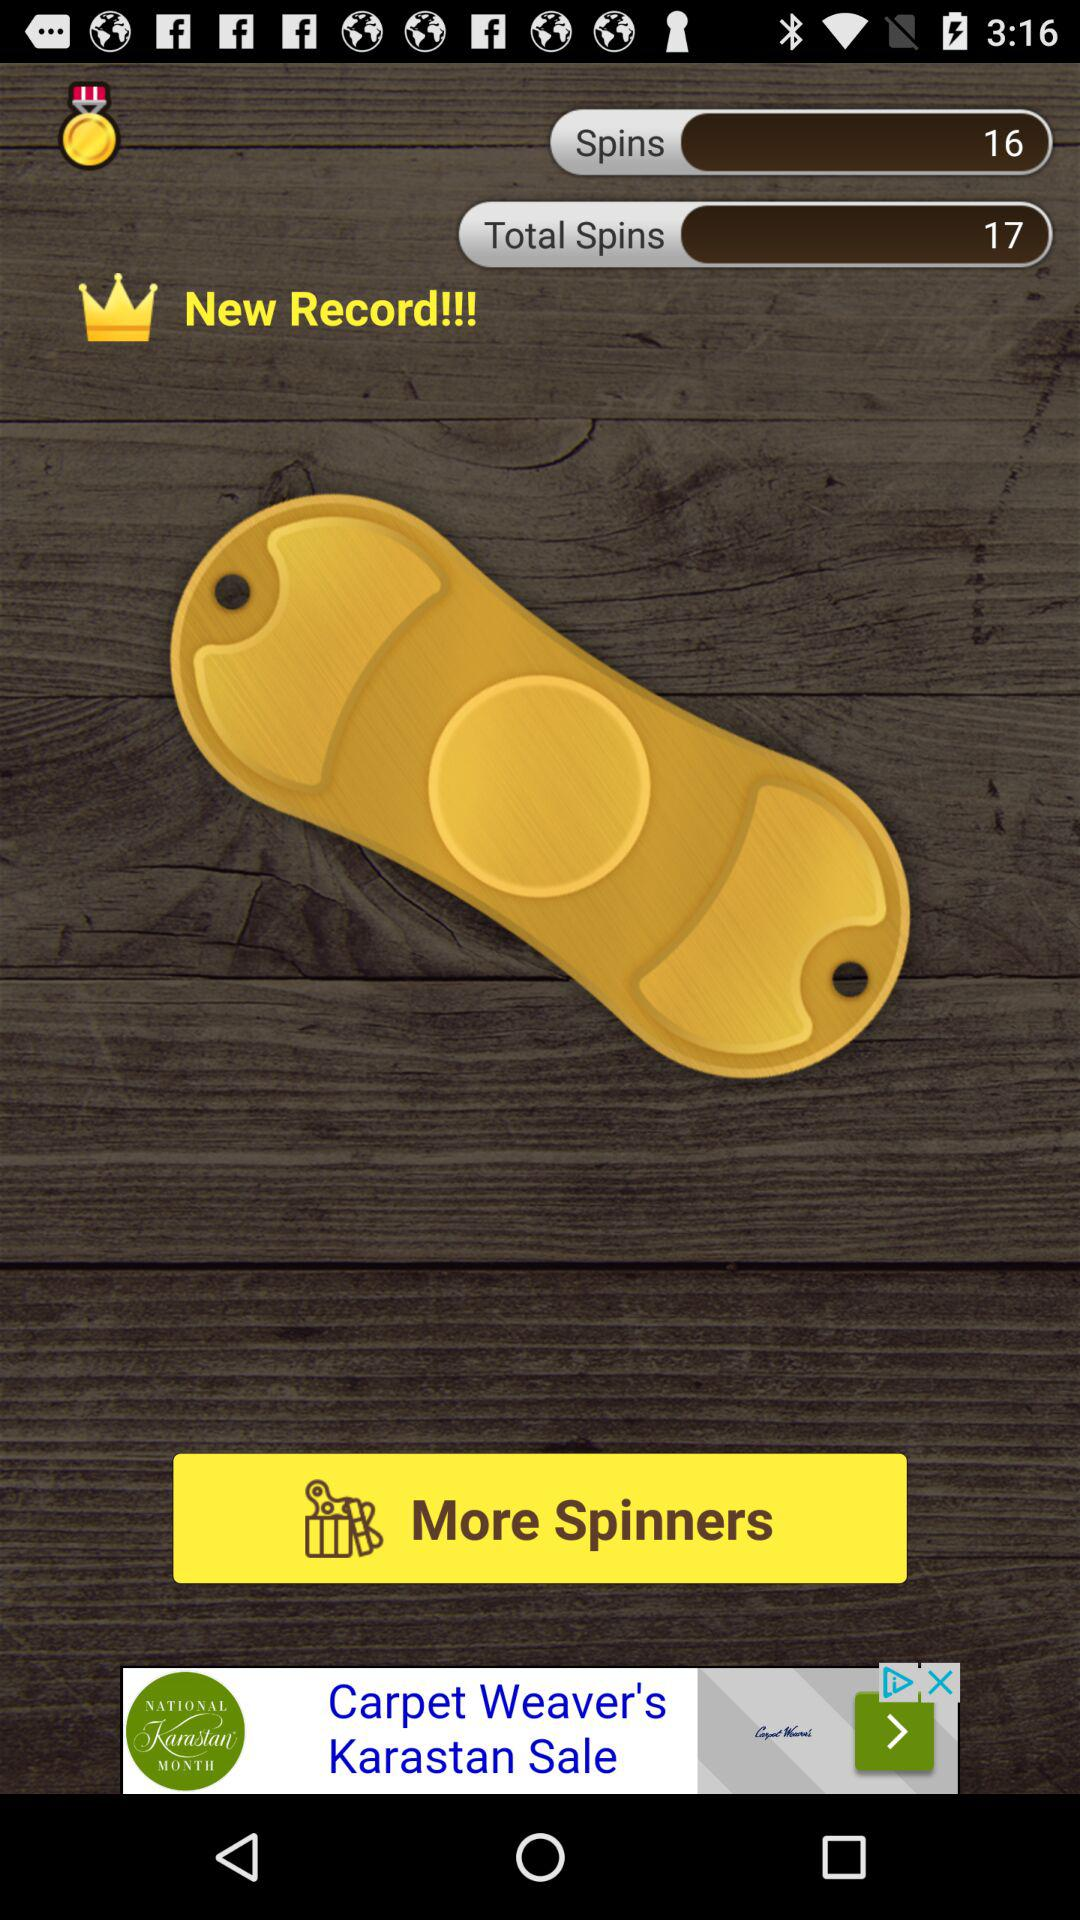How many more spins did I get in this round than my previous record?
Answer the question using a single word or phrase. 1 